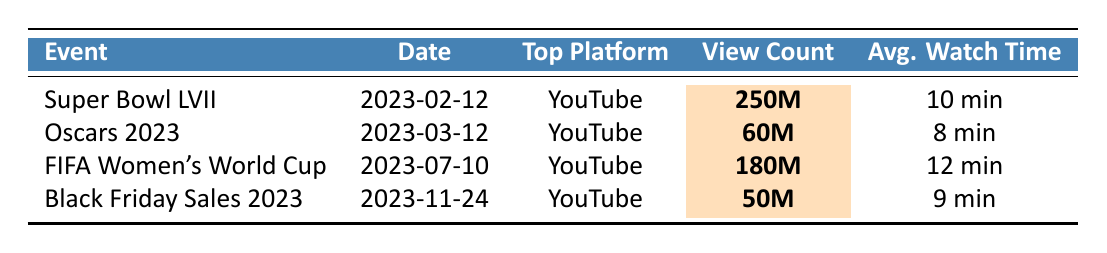What is the total view count of Super Bowl LVII across all platforms? The view counts across different platforms for Super Bowl LVII are: YouTube (250M), Twitch (15M), and Facebook Watch (8M). Adding these gives 250M + 15M + 8M = 273M views.
Answer: 273M Which event had the highest average watch time on YouTube? The average watch times on YouTube for each event are: Super Bowl LVII (10 min), Oscars 2023 (8 min), FIFA Women's World Cup (12 min), and Black Friday Sales 2023 (9 min). The highest among these is 12 min for the FIFA Women's World Cup.
Answer: FIFA Women's World Cup How many views did the Oscars 2023 receive in total? The view counts for the Oscars 2023 are: YouTube (60M), Twitch (3M), and Twitter Spaces (2M). Summing these gives 60M + 3M + 2M = 65M views.
Answer: 65M Did any event exceed 200M views on YouTube? Only Super Bowl LVII has a view count of 250M on YouTube which exceeds 200M; the others do not.
Answer: Yes What is the difference in average watch time between the FIFA Women's World Cup and the Oscars 2023 on YouTube? The average watch time for FIFA Women's World Cup on YouTube is 12 min and for Oscars 2023 it's 8 min. The difference is 12 min - 8 min = 4 min.
Answer: 4 minutes Which event had the lowest view count on platforms other than YouTube? For each event, other platform view counts are: Super Bowl LVII (15M + 8M), Oscars 2023 (3M + 2M), FIFA Women's World Cup (50M + 120M), and Black Friday Sales 2023 (12M + 8.5M). The lowest total is from the Oscars 2023: 3M + 2M = 5M.
Answer: Oscars 2023 Which platforms had the highest peak viewers during the events? The highest peak viewers for each event are: Super Bowl LVII (2M), Oscars 2023 (500K), FIFA Women's World Cup (3M), and Black Friday Sales 2023 (400K). The platform with the highest peak viewers is FIFA Women's World Cup at 3M.
Answer: FIFA Women's World Cup What percentage of views for the Black Friday Sales 2023 came from YouTube? The total views for Black Friday Sales 2023 are: YouTube (50M), Instagram Live (12M), and Facebook Live (8.5M). The total is 70.5M. The percentage from YouTube is (50M / 70.5M) × 100 ≈ 70.7%.
Answer: Approximately 70.7% How do the view counts for Super Bowl LVII and FIFA Women's World Cup compare? Super Bowl LVII has 250M views and FIFA Women's World Cup has 180M views. The comparison shows that Super Bowl LVII has 70M more views than FIFA Women's World Cup.
Answer: 70M more views for Super Bowl LVII Which event had the most platforms listed in the data? The events listed each have only three platforms, so there is no one event with more platforms. They are all equal in this regard.
Answer: None, they are all equal 